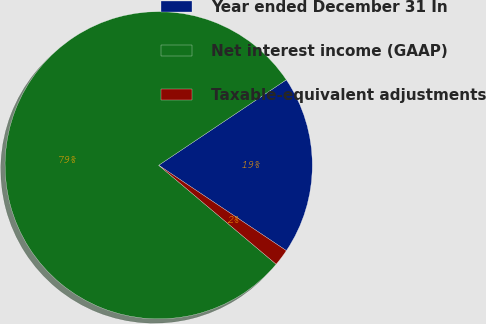Convert chart to OTSL. <chart><loc_0><loc_0><loc_500><loc_500><pie_chart><fcel>Year ended December 31 In<fcel>Net interest income (GAAP)<fcel>Taxable-equivalent adjustments<nl><fcel>18.77%<fcel>79.46%<fcel>1.76%<nl></chart> 